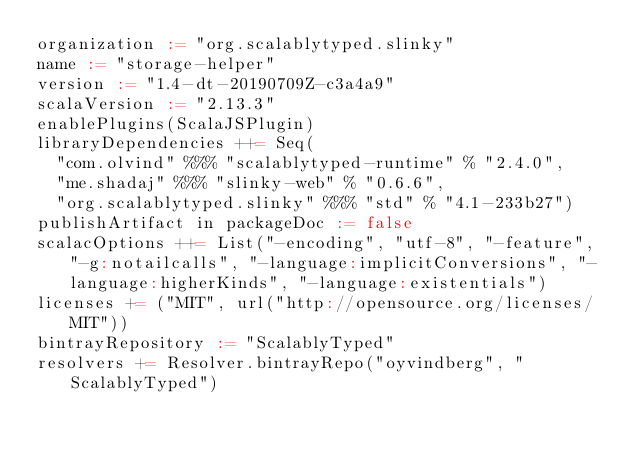<code> <loc_0><loc_0><loc_500><loc_500><_Scala_>organization := "org.scalablytyped.slinky"
name := "storage-helper"
version := "1.4-dt-20190709Z-c3a4a9"
scalaVersion := "2.13.3"
enablePlugins(ScalaJSPlugin)
libraryDependencies ++= Seq(
  "com.olvind" %%% "scalablytyped-runtime" % "2.4.0",
  "me.shadaj" %%% "slinky-web" % "0.6.6",
  "org.scalablytyped.slinky" %%% "std" % "4.1-233b27")
publishArtifact in packageDoc := false
scalacOptions ++= List("-encoding", "utf-8", "-feature", "-g:notailcalls", "-language:implicitConversions", "-language:higherKinds", "-language:existentials")
licenses += ("MIT", url("http://opensource.org/licenses/MIT"))
bintrayRepository := "ScalablyTyped"
resolvers += Resolver.bintrayRepo("oyvindberg", "ScalablyTyped")
</code> 